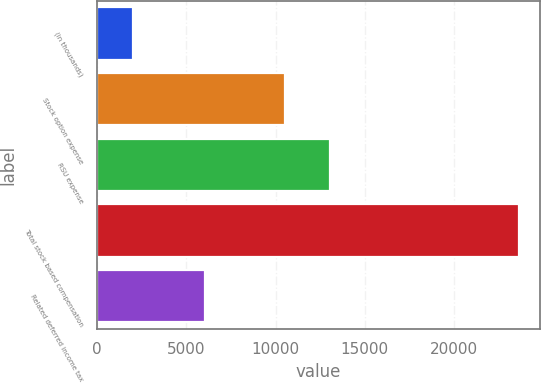Convert chart to OTSL. <chart><loc_0><loc_0><loc_500><loc_500><bar_chart><fcel>(in thousands)<fcel>Stock option expense<fcel>RSU expense<fcel>Total stock based compensation<fcel>Related deferred income tax<nl><fcel>2013<fcel>10554<fcel>13059<fcel>23613<fcel>6057<nl></chart> 